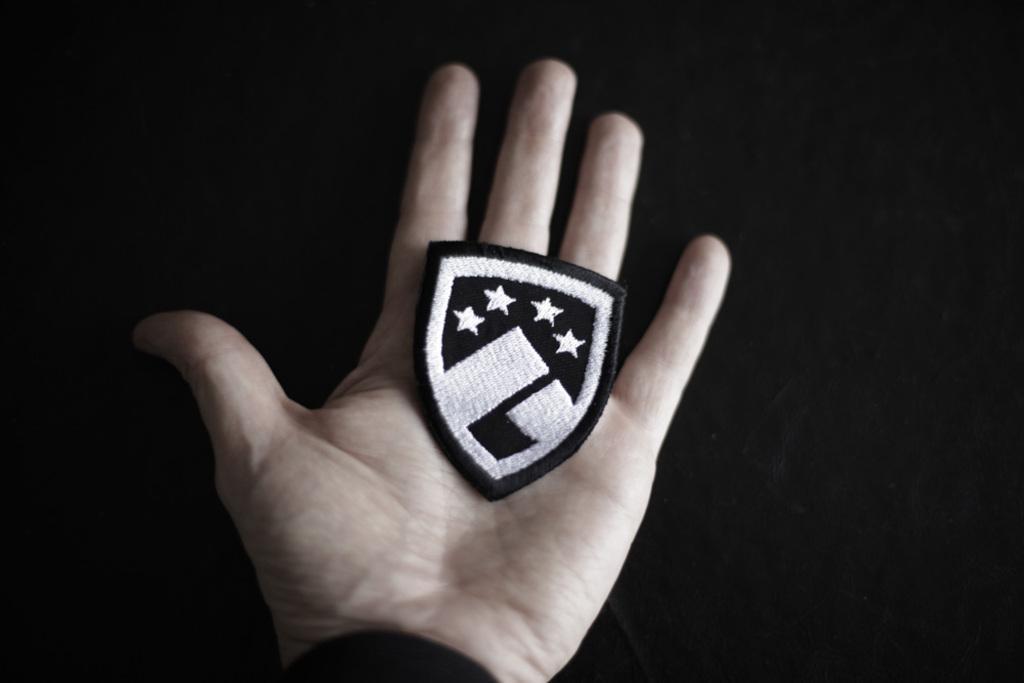In one or two sentences, can you explain what this image depicts? Here I can see a person's hand holding a black color emblem. The background is in black color. 